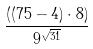Convert formula to latex. <formula><loc_0><loc_0><loc_500><loc_500>\frac { ( ( 7 5 - 4 ) \cdot 8 ) } { 9 ^ { \sqrt { 3 1 } } }</formula> 